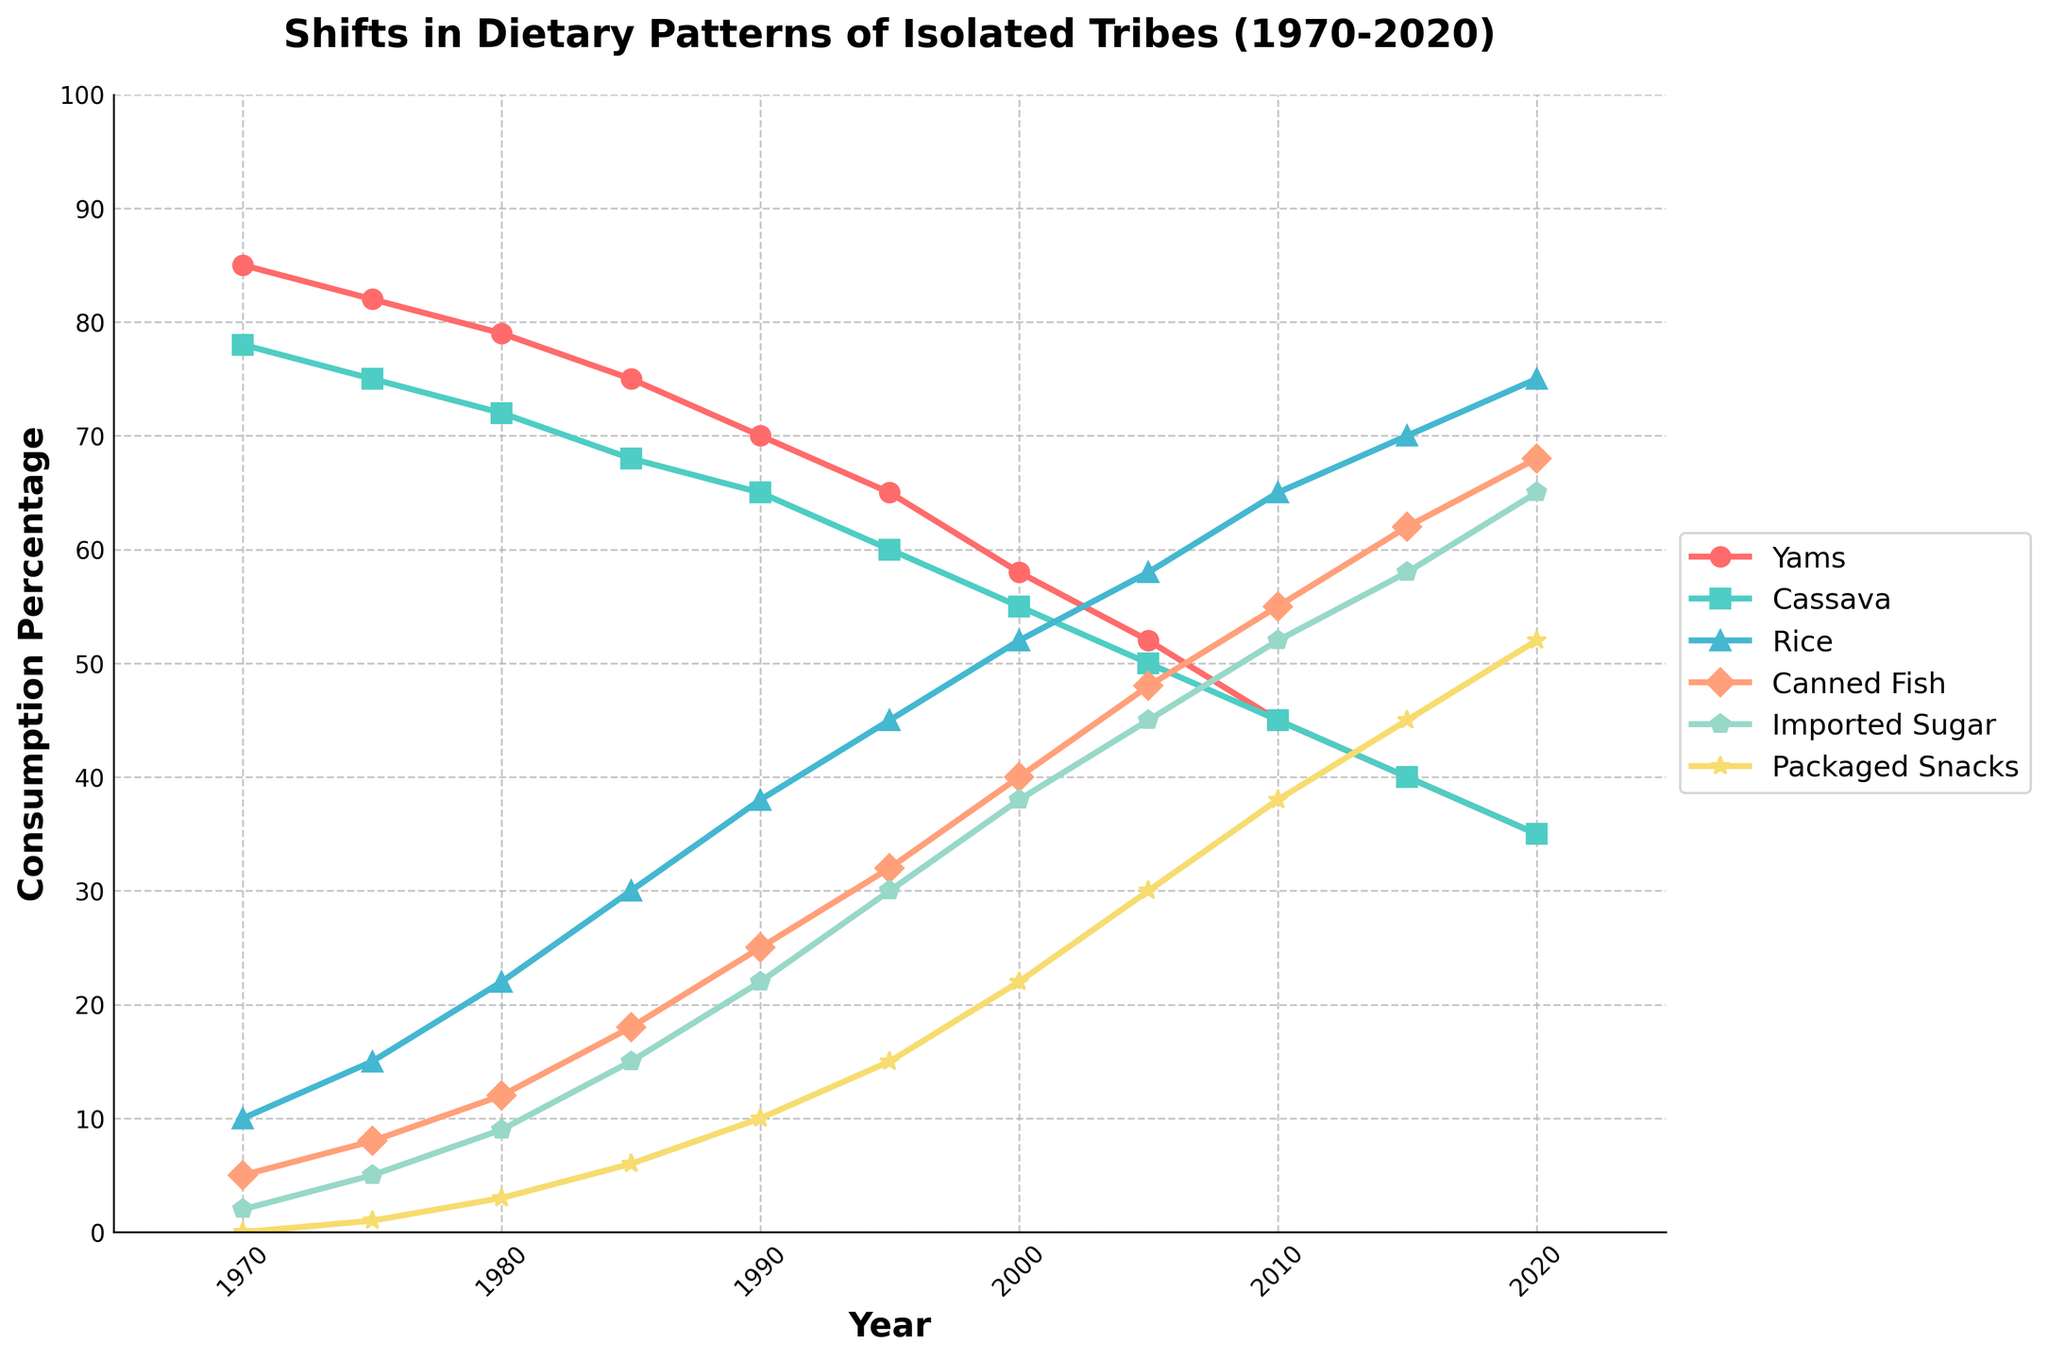What trend can be observed in the consumption of yams from 1970 to 2020? The plot shows a consistent decline in the percentage of yams consumed over the years from 1970 to 2020. The consumption starts at 85% in 1970 and reduces to 35% by 2020.
Answer: Decline Which food item had the highest increase in consumption percentage from 1970 to 2020? To determine this, check each food item's graph and measure the difference between their consumption percentages over the years. Rice shows the greatest increase from 10% in 1970 to 75% in 2020.
Answer: Rice Compare the consumption of cassava and imported sugar in 2010. Which was higher, and by how much? By examining the graph, cassava's consumption percentage in 2010 is 45%, and imported sugar's is 52%. The difference is 52 - 45 = 7%.
Answer: Imported sugar by 7% Which year did packaged snacks surpass cassava in consumption? Packaged snacks' graph surpasses cassava's between 2000 and 2005. By observing these years more closely, it is clear that packaged snacks first surpass cassava in 2005.
Answer: 2005 In 1990, what was the combined consumption percentage of rice and canned fish? For 1990, rice consumption is at 38%, and canned fish is at 25%. Summing them gives 38 + 25 = 63%.
Answer: 63% Which food item had the lowest consumption percentage in 2000, and what was that percentage? Checking the vertical positioning for 2000, yams had the lowest at 58%.
Answer: Yams, 58% What was the consumption percentage difference between yams and cassava in 1985? In 1985, yams' consumption was at 75%, and cassava's was at 68%. The difference is 75 - 68 = 7%.
Answer: 7% How did the consumption of packaged snacks change from 1975 to 2020? Initially, in 1975 packaged snacks were at 1%, then increased over time, reaching 52% by 2020, demonstrating a steady rise.
Answer: Increased steadily What is the average consumption percentage of rice over the entire period? Calculating the average value for rice’s consumption percentage over the given years: (10+15+22+30+38+45+52+58+65+70+75)/11 = 45.91%.
Answer: 45.91% 